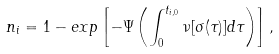Convert formula to latex. <formula><loc_0><loc_0><loc_500><loc_500>\ n _ { i } = 1 - e x p \left [ - \Psi \left ( \int _ { 0 } ^ { t _ { i , 0 } } \nu [ \sigma ( \tau ) ] d \tau \right ) \right ] ,</formula> 